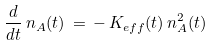<formula> <loc_0><loc_0><loc_500><loc_500>\frac { d } { d t } \, n _ { A } ( t ) \, = \, - \, K _ { e f f } ( t ) \, n ^ { 2 } _ { A } ( t )</formula> 